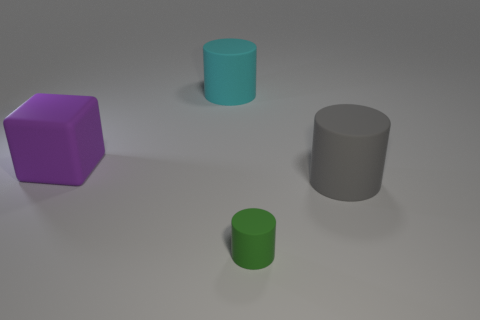Is there any other thing that has the same size as the green thing?
Your answer should be very brief. No. How many things are big gray rubber cylinders or large cyan matte cylinders?
Provide a short and direct response. 2. The big thing to the left of the cylinder that is behind the large purple rubber block is what shape?
Ensure brevity in your answer.  Cube. There is a large rubber thing to the right of the small cylinder; is its shape the same as the purple object?
Keep it short and to the point. No. What is the size of the purple object that is the same material as the large gray thing?
Provide a short and direct response. Large. What number of things are either large cylinders that are on the left side of the gray rubber thing or objects that are behind the small matte thing?
Your answer should be very brief. 3. Are there the same number of purple cubes left of the gray rubber thing and large gray rubber things behind the large purple matte block?
Provide a short and direct response. No. What color is the large rubber thing to the left of the large cyan rubber thing?
Offer a very short reply. Purple. Are there fewer large brown matte objects than purple rubber blocks?
Provide a succinct answer. Yes. What number of cyan things are the same size as the block?
Provide a succinct answer. 1. 